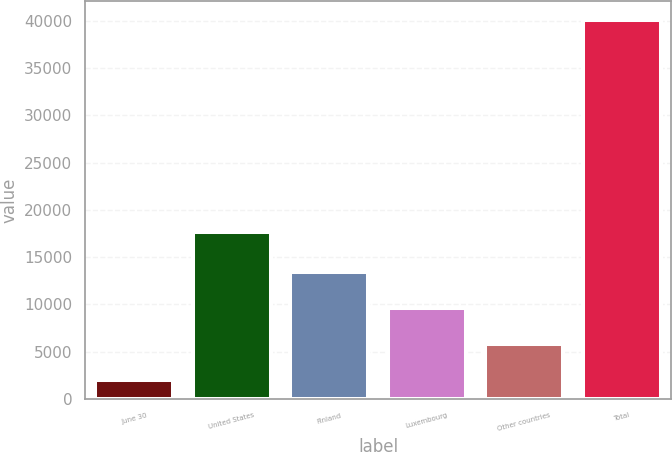<chart> <loc_0><loc_0><loc_500><loc_500><bar_chart><fcel>June 30<fcel>United States<fcel>Finland<fcel>Luxembourg<fcel>Other countries<fcel>Total<nl><fcel>2014<fcel>17653<fcel>13445.5<fcel>9635<fcel>5824.5<fcel>40119<nl></chart> 